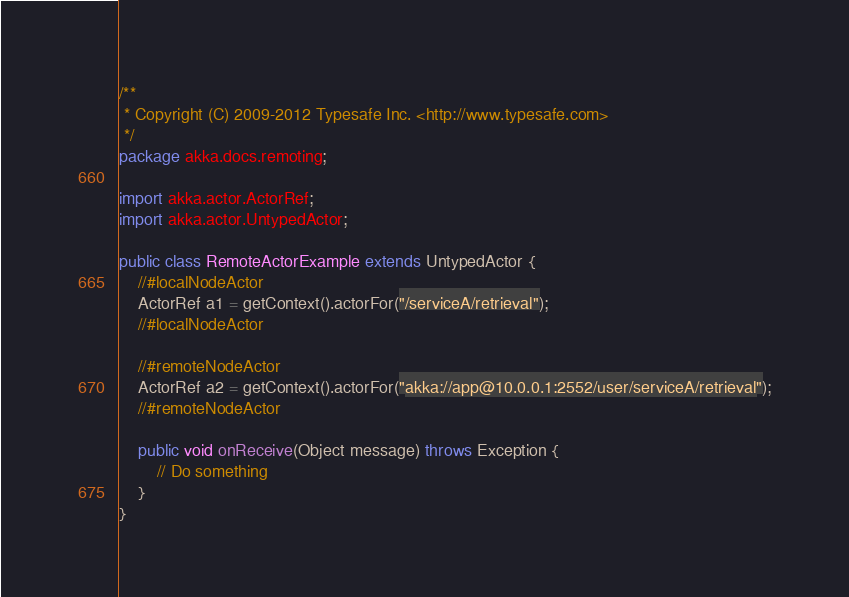<code> <loc_0><loc_0><loc_500><loc_500><_Java_>/**
 * Copyright (C) 2009-2012 Typesafe Inc. <http://www.typesafe.com>
 */
package akka.docs.remoting;

import akka.actor.ActorRef;
import akka.actor.UntypedActor;

public class RemoteActorExample extends UntypedActor {
    //#localNodeActor
    ActorRef a1 = getContext().actorFor("/serviceA/retrieval");
    //#localNodeActor

    //#remoteNodeActor
    ActorRef a2 = getContext().actorFor("akka://app@10.0.0.1:2552/user/serviceA/retrieval");
    //#remoteNodeActor

    public void onReceive(Object message) throws Exception {
        // Do something
    }
}
</code> 